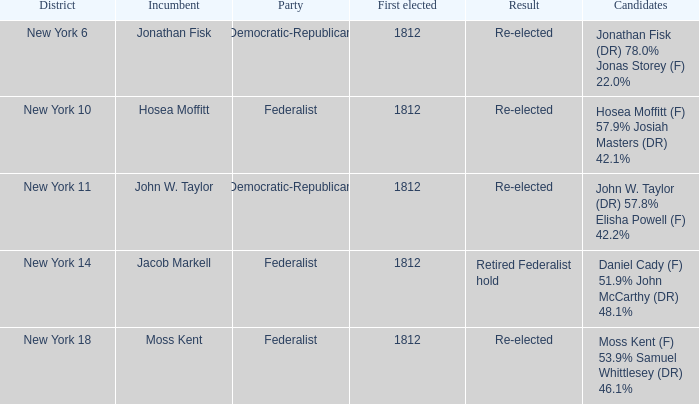9% josiah masters (dr) 4 1812.0. 